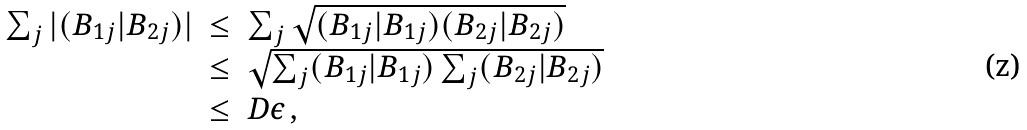Convert formula to latex. <formula><loc_0><loc_0><loc_500><loc_500>\begin{array} { r c l } \sum _ { j } | ( B _ { 1 j } | B _ { 2 j } ) | & \leq & \sum _ { j } \sqrt { ( B _ { 1 j } | B _ { 1 j } ) ( B _ { 2 j } | B _ { 2 j } ) } \\ & \leq & \sqrt { \sum _ { j } ( B _ { 1 j } | B _ { 1 j } ) \sum _ { j } ( B _ { 2 j } | B _ { 2 j } ) } \\ & \leq & D \epsilon \, , \end{array}</formula> 